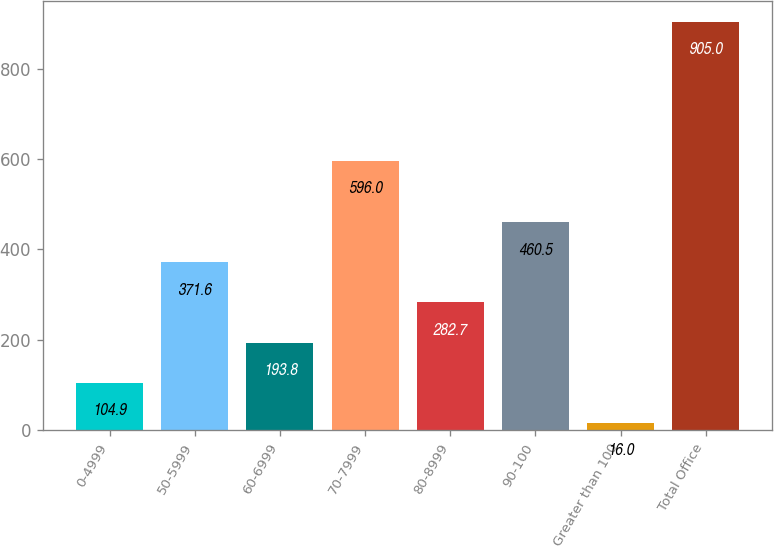<chart> <loc_0><loc_0><loc_500><loc_500><bar_chart><fcel>0-4999<fcel>50-5999<fcel>60-6999<fcel>70-7999<fcel>80-8999<fcel>90-100<fcel>Greater than 100<fcel>Total Office<nl><fcel>104.9<fcel>371.6<fcel>193.8<fcel>596<fcel>282.7<fcel>460.5<fcel>16<fcel>905<nl></chart> 